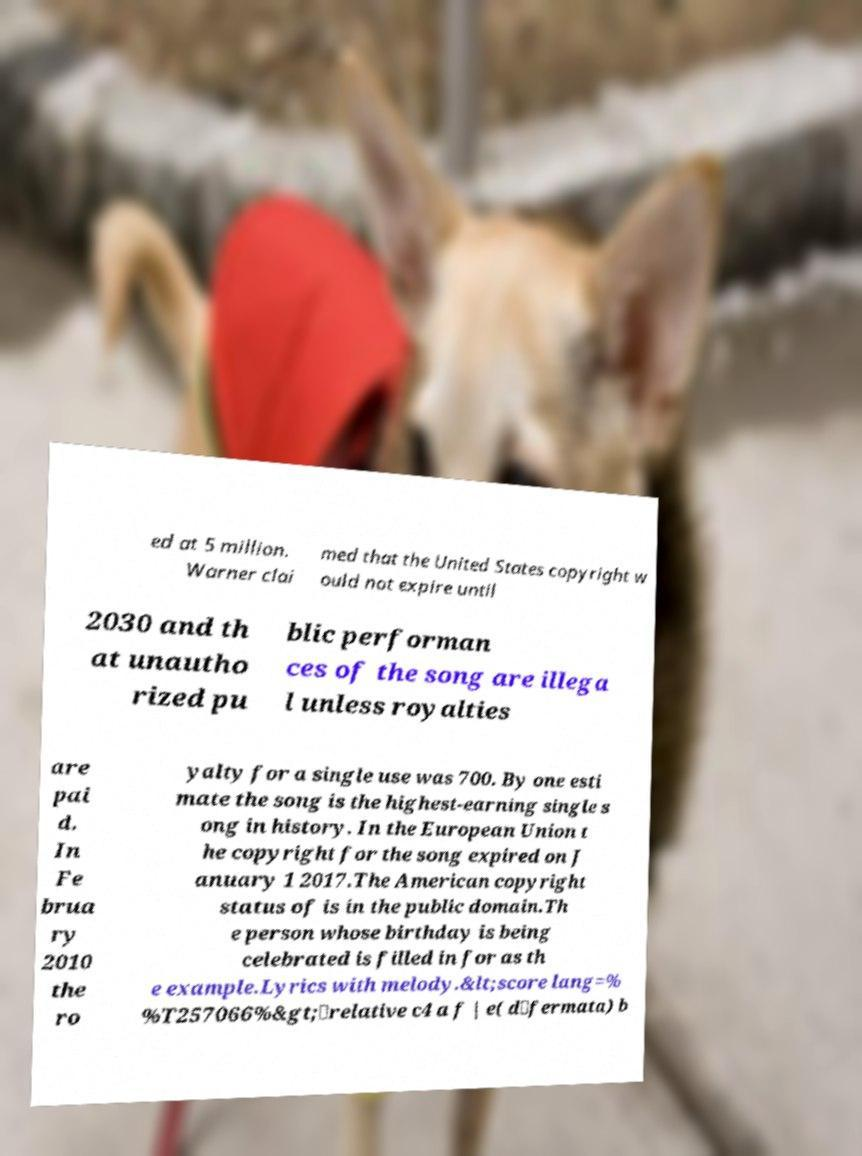Can you accurately transcribe the text from the provided image for me? ed at 5 million. Warner clai med that the United States copyright w ould not expire until 2030 and th at unautho rized pu blic performan ces of the song are illega l unless royalties are pai d. In Fe brua ry 2010 the ro yalty for a single use was 700. By one esti mate the song is the highest-earning single s ong in history. In the European Union t he copyright for the song expired on J anuary 1 2017.The American copyright status of is in the public domain.Th e person whose birthday is being celebrated is filled in for as th e example.Lyrics with melody.&lt;score lang=% %T257066%&gt;\relative c4 a f | e( d\fermata) b 